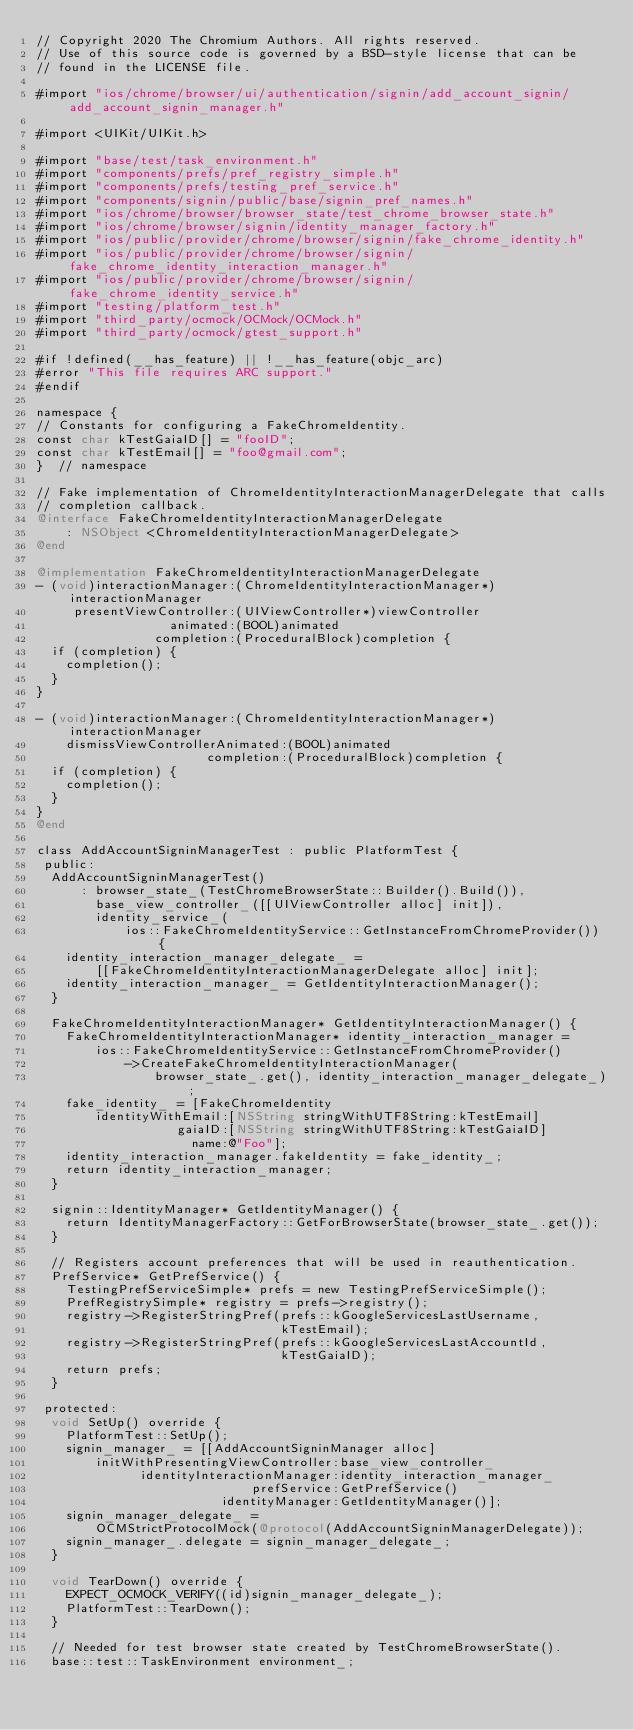<code> <loc_0><loc_0><loc_500><loc_500><_ObjectiveC_>// Copyright 2020 The Chromium Authors. All rights reserved.
// Use of this source code is governed by a BSD-style license that can be
// found in the LICENSE file.

#import "ios/chrome/browser/ui/authentication/signin/add_account_signin/add_account_signin_manager.h"

#import <UIKit/UIKit.h>

#import "base/test/task_environment.h"
#import "components/prefs/pref_registry_simple.h"
#import "components/prefs/testing_pref_service.h"
#import "components/signin/public/base/signin_pref_names.h"
#import "ios/chrome/browser/browser_state/test_chrome_browser_state.h"
#import "ios/chrome/browser/signin/identity_manager_factory.h"
#import "ios/public/provider/chrome/browser/signin/fake_chrome_identity.h"
#import "ios/public/provider/chrome/browser/signin/fake_chrome_identity_interaction_manager.h"
#import "ios/public/provider/chrome/browser/signin/fake_chrome_identity_service.h"
#import "testing/platform_test.h"
#import "third_party/ocmock/OCMock/OCMock.h"
#import "third_party/ocmock/gtest_support.h"

#if !defined(__has_feature) || !__has_feature(objc_arc)
#error "This file requires ARC support."
#endif

namespace {
// Constants for configuring a FakeChromeIdentity.
const char kTestGaiaID[] = "fooID";
const char kTestEmail[] = "foo@gmail.com";
}  // namespace

// Fake implementation of ChromeIdentityInteractionManagerDelegate that calls
// completion callback.
@interface FakeChromeIdentityInteractionManagerDelegate
    : NSObject <ChromeIdentityInteractionManagerDelegate>
@end

@implementation FakeChromeIdentityInteractionManagerDelegate
- (void)interactionManager:(ChromeIdentityInteractionManager*)interactionManager
     presentViewController:(UIViewController*)viewController
                  animated:(BOOL)animated
                completion:(ProceduralBlock)completion {
  if (completion) {
    completion();
  }
}

- (void)interactionManager:(ChromeIdentityInteractionManager*)interactionManager
    dismissViewControllerAnimated:(BOOL)animated
                       completion:(ProceduralBlock)completion {
  if (completion) {
    completion();
  }
}
@end

class AddAccountSigninManagerTest : public PlatformTest {
 public:
  AddAccountSigninManagerTest()
      : browser_state_(TestChromeBrowserState::Builder().Build()),
        base_view_controller_([[UIViewController alloc] init]),
        identity_service_(
            ios::FakeChromeIdentityService::GetInstanceFromChromeProvider()) {
    identity_interaction_manager_delegate_ =
        [[FakeChromeIdentityInteractionManagerDelegate alloc] init];
    identity_interaction_manager_ = GetIdentityInteractionManager();
  }

  FakeChromeIdentityInteractionManager* GetIdentityInteractionManager() {
    FakeChromeIdentityInteractionManager* identity_interaction_manager =
        ios::FakeChromeIdentityService::GetInstanceFromChromeProvider()
            ->CreateFakeChromeIdentityInteractionManager(
                browser_state_.get(), identity_interaction_manager_delegate_);
    fake_identity_ = [FakeChromeIdentity
        identityWithEmail:[NSString stringWithUTF8String:kTestEmail]
                   gaiaID:[NSString stringWithUTF8String:kTestGaiaID]
                     name:@"Foo"];
    identity_interaction_manager.fakeIdentity = fake_identity_;
    return identity_interaction_manager;
  }

  signin::IdentityManager* GetIdentityManager() {
    return IdentityManagerFactory::GetForBrowserState(browser_state_.get());
  }

  // Registers account preferences that will be used in reauthentication.
  PrefService* GetPrefService() {
    TestingPrefServiceSimple* prefs = new TestingPrefServiceSimple();
    PrefRegistrySimple* registry = prefs->registry();
    registry->RegisterStringPref(prefs::kGoogleServicesLastUsername,
                                 kTestEmail);
    registry->RegisterStringPref(prefs::kGoogleServicesLastAccountId,
                                 kTestGaiaID);
    return prefs;
  }

 protected:
  void SetUp() override {
    PlatformTest::SetUp();
    signin_manager_ = [[AddAccountSigninManager alloc]
        initWithPresentingViewController:base_view_controller_
              identityInteractionManager:identity_interaction_manager_
                             prefService:GetPrefService()
                         identityManager:GetIdentityManager()];
    signin_manager_delegate_ =
        OCMStrictProtocolMock(@protocol(AddAccountSigninManagerDelegate));
    signin_manager_.delegate = signin_manager_delegate_;
  }

  void TearDown() override {
    EXPECT_OCMOCK_VERIFY((id)signin_manager_delegate_);
    PlatformTest::TearDown();
  }

  // Needed for test browser state created by TestChromeBrowserState().
  base::test::TaskEnvironment environment_;</code> 